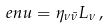Convert formula to latex. <formula><loc_0><loc_0><loc_500><loc_500>\ e n u = \eta _ { \nu \bar { \nu } } L _ { \nu } \, ,</formula> 